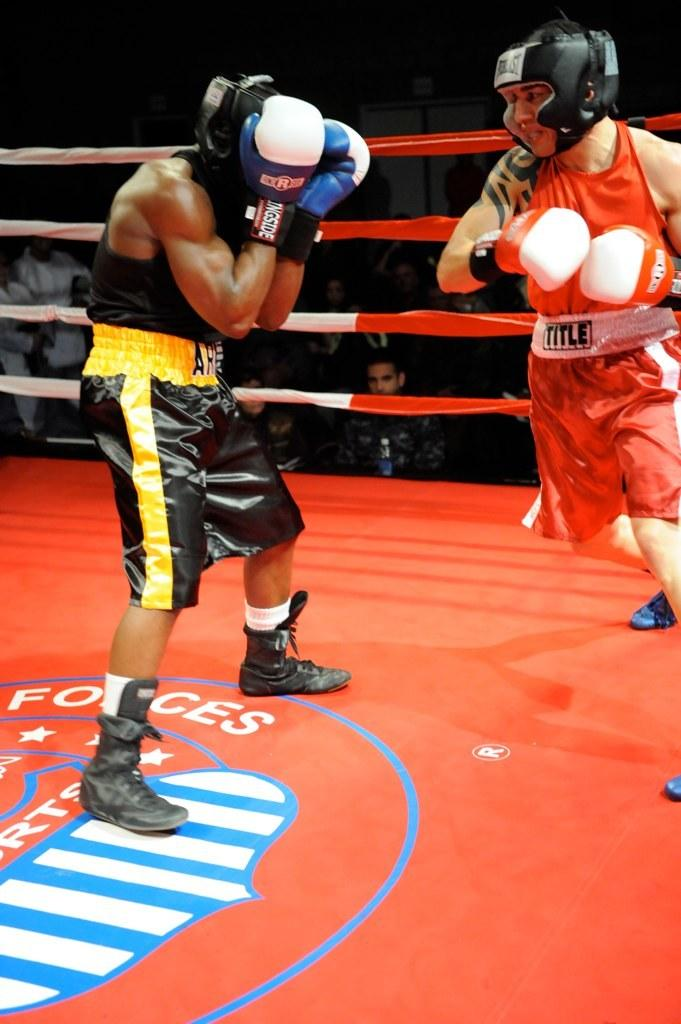<image>
Describe the image concisely. Two men in a boxing ring with a Forces logo on the floor 